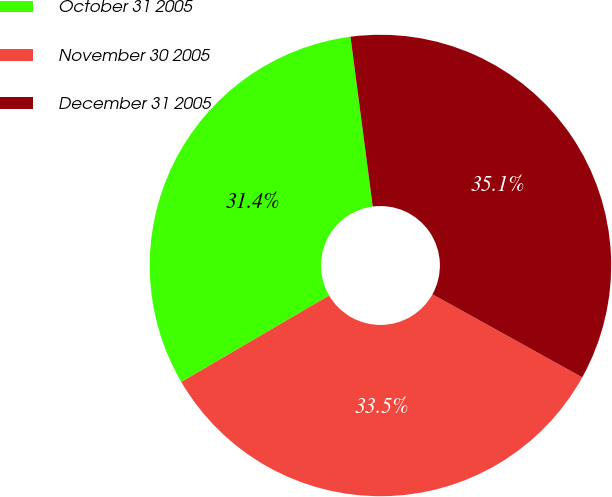Convert chart. <chart><loc_0><loc_0><loc_500><loc_500><pie_chart><fcel>October 31 2005<fcel>November 30 2005<fcel>December 31 2005<nl><fcel>31.35%<fcel>33.52%<fcel>35.13%<nl></chart> 